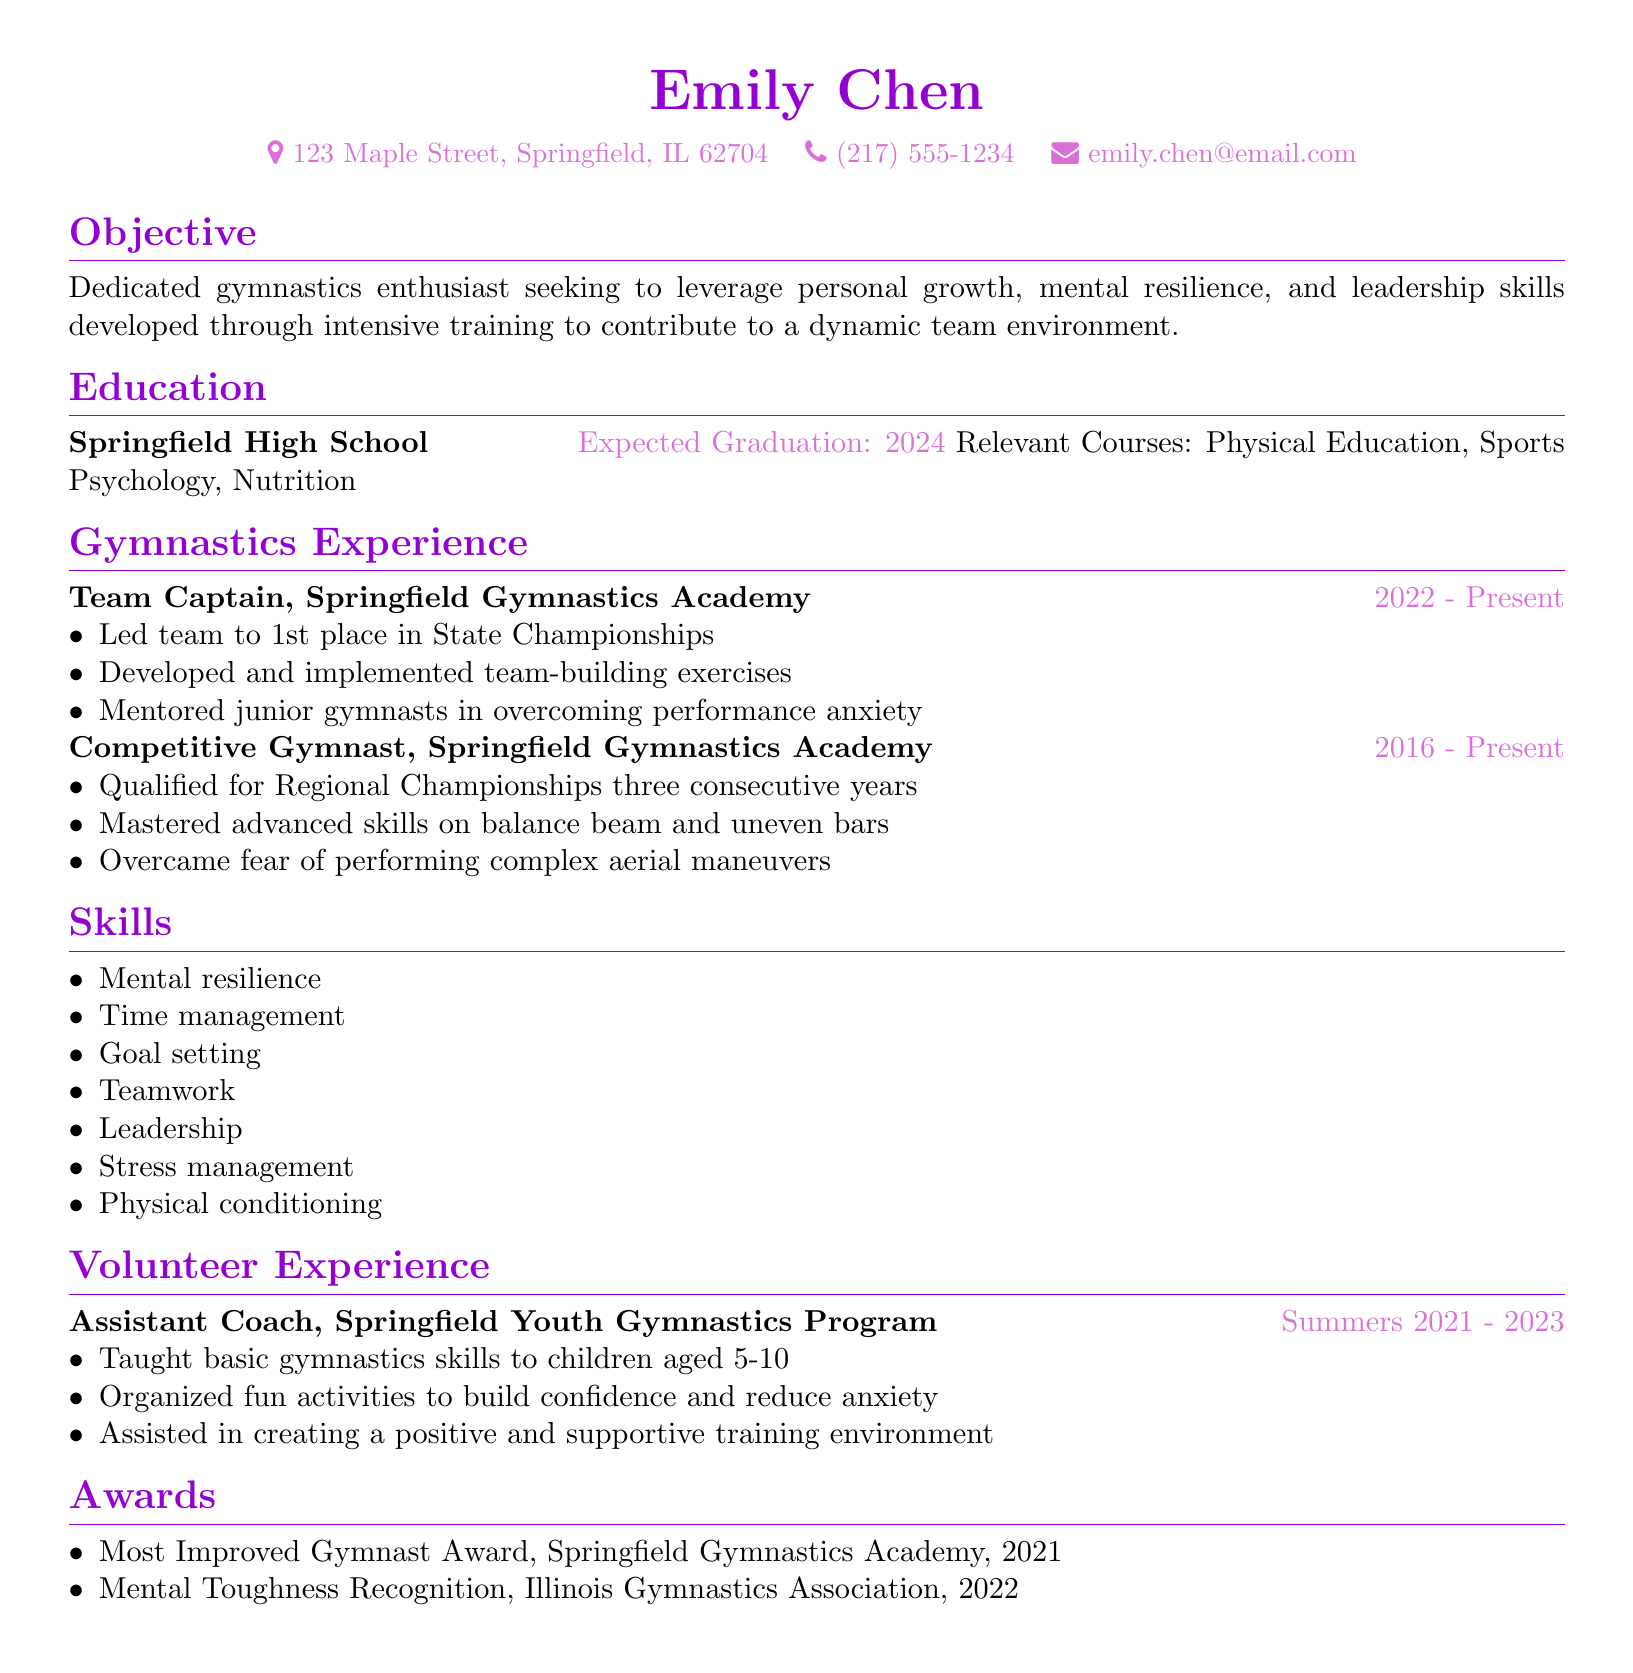what is the name of the individual? The name of the individual is found in the personal information section of the CV.
Answer: Emily Chen what is the expected graduation year? The expected graduation year is listed under the education section.
Answer: 2024 what position does Emily hold at the Springfield Gymnastics Academy? The position held is specified in the gymnastics experience section.
Answer: Team Captain how many consecutive years did Emily qualify for the Regional Championships? This information is mentioned in the competitive gymnast experience section.
Answer: three what award did Emily receive in 2021? The award is listed under the awards section of the CV.
Answer: Most Improved Gymnast Award what skill related to managing stress is mentioned? This skill can be found in the skills section of the CV.
Answer: Stress management what was one responsibility of Emily as an Assistant Coach? The responsibilities are detailed in the volunteer experience section, highlighting her role.
Answer: Taught basic gymnastics skills to children aged 5-10 what team achievement did Emily's team accomplish? This information is included in the gymnastics experience section regarding a championship.
Answer: 1st place in State Championships what courses related to sports did Emily take? The relevant courses are listed under her education.
Answer: Physical Education, Sports Psychology, Nutrition 